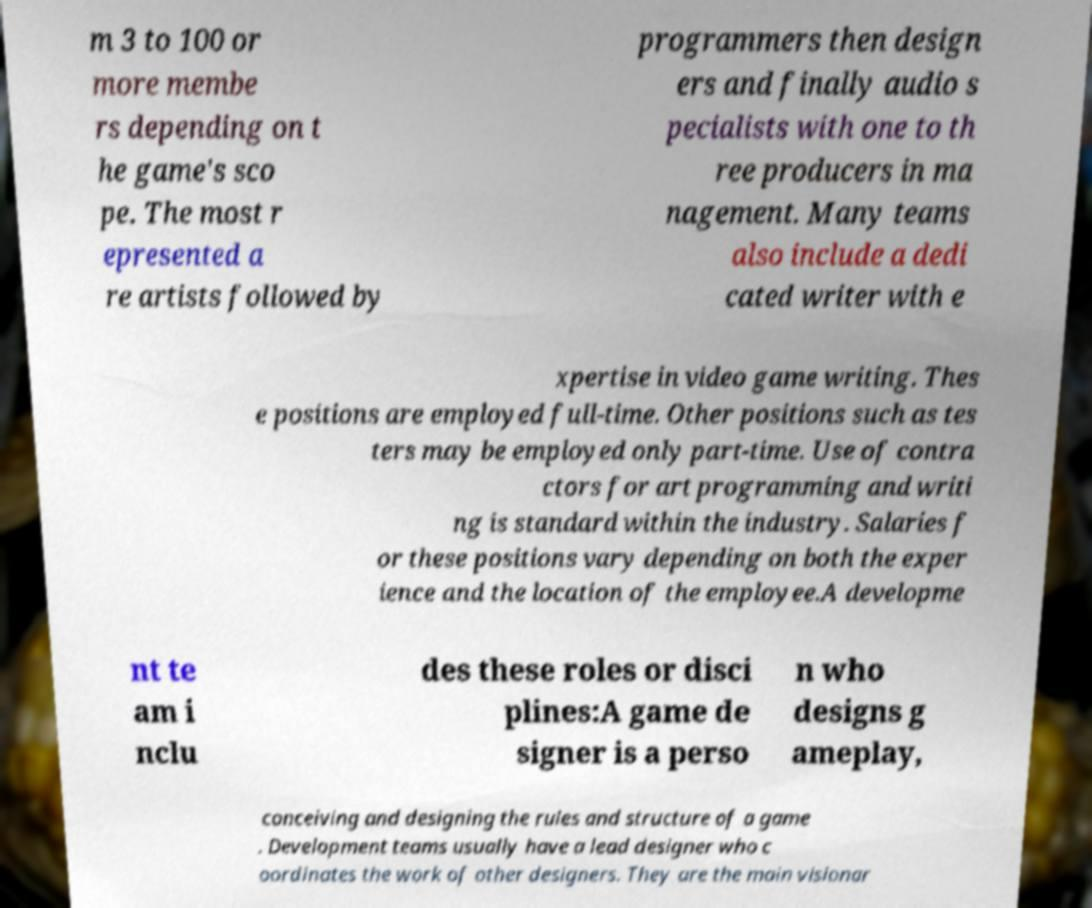For documentation purposes, I need the text within this image transcribed. Could you provide that? m 3 to 100 or more membe rs depending on t he game's sco pe. The most r epresented a re artists followed by programmers then design ers and finally audio s pecialists with one to th ree producers in ma nagement. Many teams also include a dedi cated writer with e xpertise in video game writing. Thes e positions are employed full-time. Other positions such as tes ters may be employed only part-time. Use of contra ctors for art programming and writi ng is standard within the industry. Salaries f or these positions vary depending on both the exper ience and the location of the employee.A developme nt te am i nclu des these roles or disci plines:A game de signer is a perso n who designs g ameplay, conceiving and designing the rules and structure of a game . Development teams usually have a lead designer who c oordinates the work of other designers. They are the main visionar 